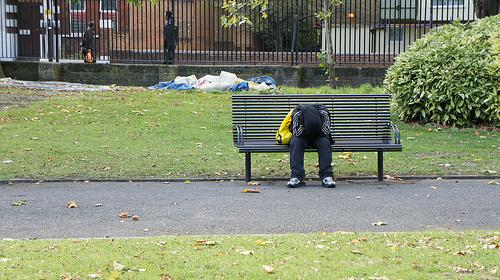List the important objects and people present in the image. Person wearing hood, black bench, grey ground, leaves on grass, garbage, black fence, bushes, people in background, yellow bag, pile of trash. Write a brief introduction to a novel based on the image. As the hooded figure sat on the black bench in the park, little did they know their life would soon change forever, just as the leaves continue to fall around them, bringing new beginnings after each season. Narrate the scene as if you were telling a story. Once upon a time, in a quiet park, a mysterious person in a hood sat on a black bench, contemplating life, while fallen leaves danced nearby, and the world went on beyond the fence. Summarize the scene in a single sentence. A hooded person sits alone on a black bench in the park, surrounded by fallen leaves, a grey pathway, and a distant black fence. Briefly talk about the most prominent features in the image. A person is sitting on a black bench in a park, wearing a hood, with brown leaves on the ground, a grey walkway, and a black fence in the background. Explain the setting and mood of the image. The image takes place in a serene park setting, with the mood being quiet and reflective as a person in a hood sits on a bench, surrounded by nature and people in the distance. Write a news headline about the image. "Solitary Figure Finds Peace on Park Bench Amidst the Bustle of City Life: A Moment Captured" Describe the colors and textures present in the image. The image showcases the vibrant hues of black bench, grey ground, and various shades of brown leaves, combined with lush green grass and the sharp lines of the black fence. Mention the key elements of the image in a poetic manner. Amidst fallen leaves, a hooded figure finds solace on the black wooden bench, as the distant fence stands guard, a silent sentinel in this tranquil park. Write a short haiku about the image. In the park, time stills. 